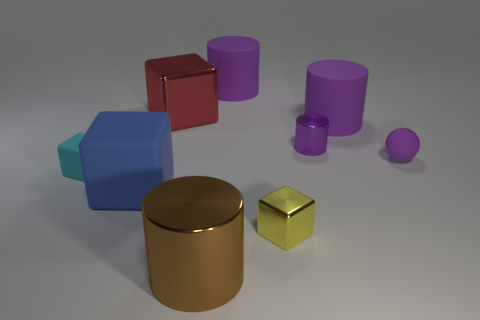Subtract all purple cylinders. How many cylinders are left? 1 Subtract all red cubes. How many purple cylinders are left? 3 Subtract 1 blocks. How many blocks are left? 3 Subtract all red cubes. How many cubes are left? 3 Subtract all cylinders. How many objects are left? 5 Subtract all purple cubes. Subtract all gray spheres. How many cubes are left? 4 Add 4 green metal cubes. How many green metal cubes exist? 4 Subtract 0 green balls. How many objects are left? 9 Subtract all rubber balls. Subtract all brown metallic cylinders. How many objects are left? 7 Add 8 big brown cylinders. How many big brown cylinders are left? 9 